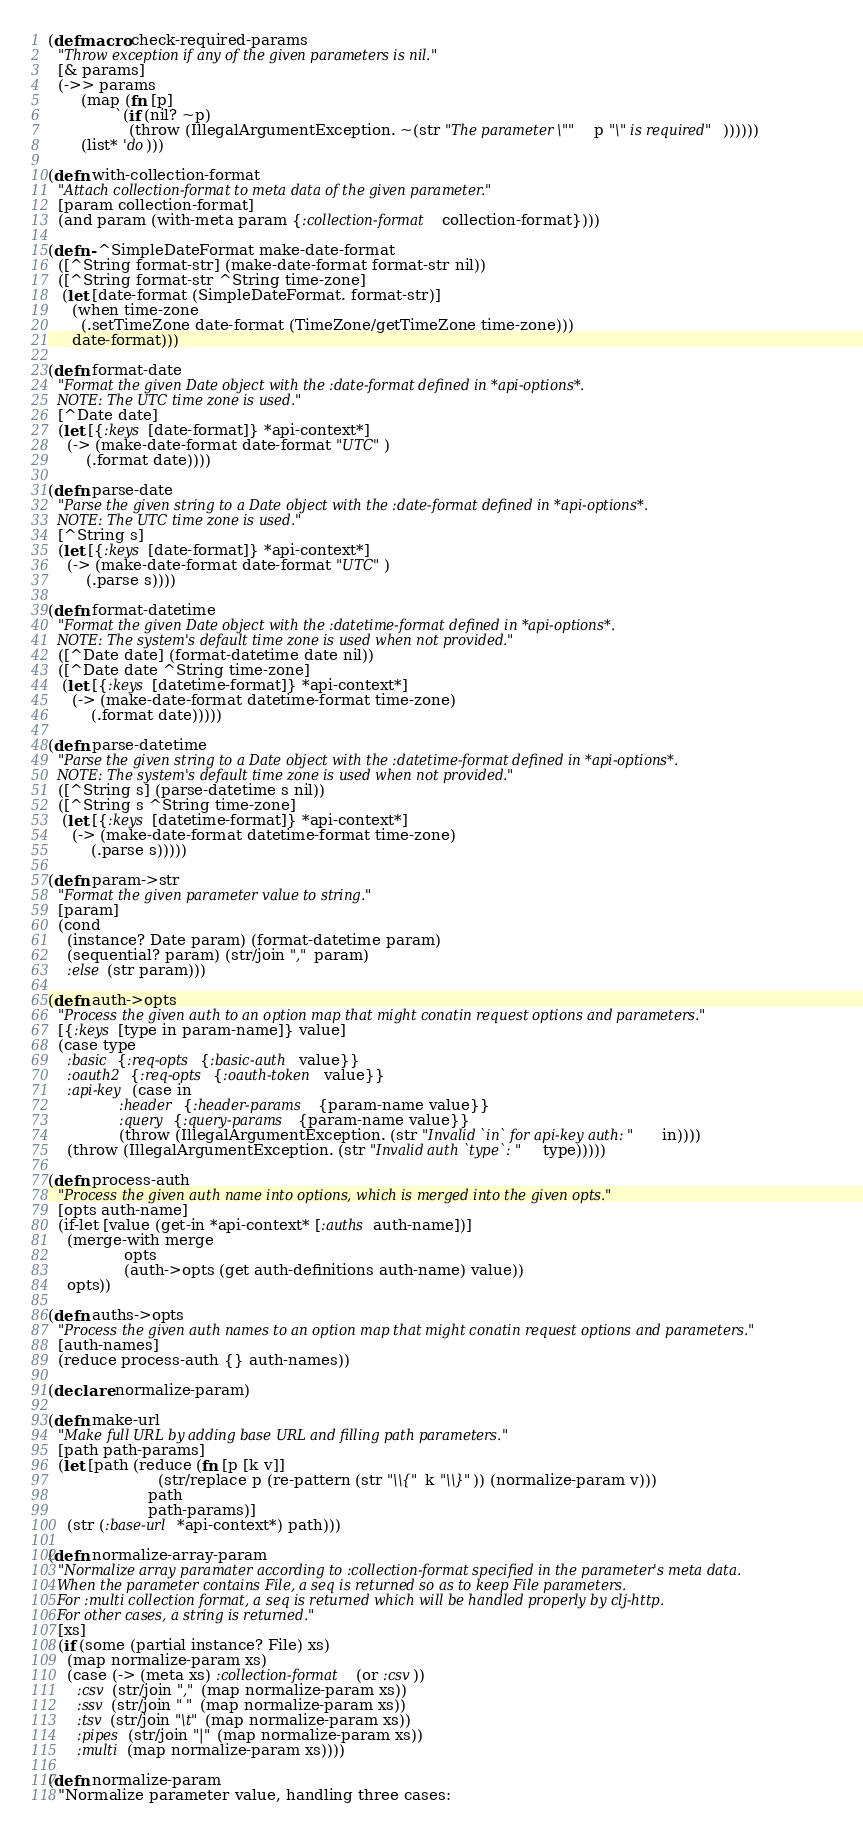Convert code to text. <code><loc_0><loc_0><loc_500><loc_500><_Clojure_>(defmacro check-required-params
  "Throw exception if any of the given parameters is nil."
  [& params]
  (->> params
       (map (fn [p]
              `(if (nil? ~p)
                 (throw (IllegalArgumentException. ~(str "The parameter \"" p "\" is required"))))))
       (list* 'do)))

(defn with-collection-format
  "Attach collection-format to meta data of the given parameter."
  [param collection-format]
  (and param (with-meta param {:collection-format collection-format})))

(defn- ^SimpleDateFormat make-date-format
  ([^String format-str] (make-date-format format-str nil))
  ([^String format-str ^String time-zone]
   (let [date-format (SimpleDateFormat. format-str)]
     (when time-zone
       (.setTimeZone date-format (TimeZone/getTimeZone time-zone)))
     date-format)))

(defn format-date
  "Format the given Date object with the :date-format defined in *api-options*.
  NOTE: The UTC time zone is used."
  [^Date date]
  (let [{:keys [date-format]} *api-context*]
    (-> (make-date-format date-format "UTC")
        (.format date))))

(defn parse-date
  "Parse the given string to a Date object with the :date-format defined in *api-options*.
  NOTE: The UTC time zone is used."
  [^String s]
  (let [{:keys [date-format]} *api-context*]
    (-> (make-date-format date-format "UTC")
        (.parse s))))

(defn format-datetime
  "Format the given Date object with the :datetime-format defined in *api-options*.
  NOTE: The system's default time zone is used when not provided."
  ([^Date date] (format-datetime date nil))
  ([^Date date ^String time-zone]
   (let [{:keys [datetime-format]} *api-context*]
     (-> (make-date-format datetime-format time-zone)
         (.format date)))))

(defn parse-datetime
  "Parse the given string to a Date object with the :datetime-format defined in *api-options*.
  NOTE: The system's default time zone is used when not provided."
  ([^String s] (parse-datetime s nil))
  ([^String s ^String time-zone]
   (let [{:keys [datetime-format]} *api-context*]
     (-> (make-date-format datetime-format time-zone)
         (.parse s)))))

(defn param->str
  "Format the given parameter value to string."
  [param]
  (cond
    (instance? Date param) (format-datetime param)
    (sequential? param) (str/join "," param)
    :else (str param)))

(defn auth->opts
  "Process the given auth to an option map that might conatin request options and parameters."
  [{:keys [type in param-name]} value]
  (case type
    :basic {:req-opts {:basic-auth value}}
    :oauth2 {:req-opts {:oauth-token value}}
    :api-key (case in
               :header {:header-params {param-name value}}
               :query {:query-params {param-name value}}
               (throw (IllegalArgumentException. (str "Invalid `in` for api-key auth: " in))))
    (throw (IllegalArgumentException. (str "Invalid auth `type`: " type)))))

(defn process-auth
  "Process the given auth name into options, which is merged into the given opts."
  [opts auth-name]
  (if-let [value (get-in *api-context* [:auths auth-name])]
    (merge-with merge
                opts
                (auth->opts (get auth-definitions auth-name) value))
    opts))

(defn auths->opts
  "Process the given auth names to an option map that might conatin request options and parameters."
  [auth-names]
  (reduce process-auth {} auth-names))

(declare normalize-param)

(defn make-url
  "Make full URL by adding base URL and filling path parameters."
  [path path-params]
  (let [path (reduce (fn [p [k v]]
                       (str/replace p (re-pattern (str "\\{" k "\\}")) (normalize-param v)))
                     path
                     path-params)]
    (str (:base-url *api-context*) path)))

(defn normalize-array-param
  "Normalize array paramater according to :collection-format specified in the parameter's meta data.
  When the parameter contains File, a seq is returned so as to keep File parameters.
  For :multi collection format, a seq is returned which will be handled properly by clj-http.
  For other cases, a string is returned."
  [xs]
  (if (some (partial instance? File) xs)
    (map normalize-param xs)
    (case (-> (meta xs) :collection-format (or :csv))
      :csv (str/join "," (map normalize-param xs))
      :ssv (str/join " " (map normalize-param xs))
      :tsv (str/join "\t" (map normalize-param xs))
      :pipes (str/join "|" (map normalize-param xs))
      :multi (map normalize-param xs))))

(defn normalize-param
  "Normalize parameter value, handling three cases:</code> 